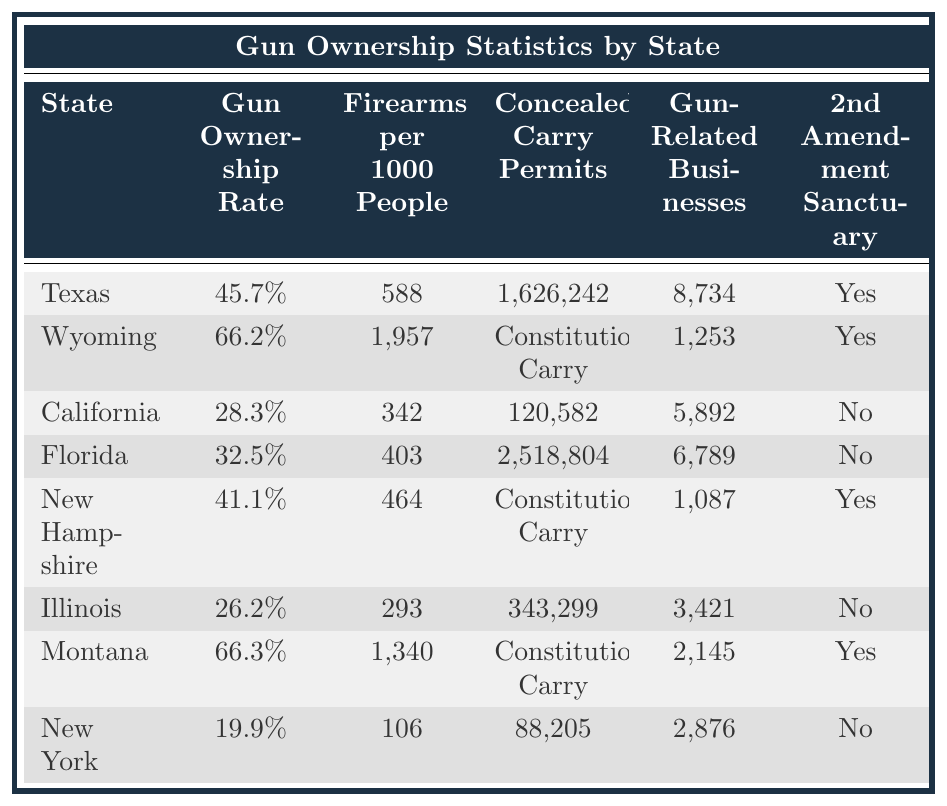What is the gun ownership rate in Texas? The table specifies the gun ownership rate for Texas as 45.7%.
Answer: 45.7% Which state has the highest firearms per 1000 people? In the table, Wyoming shows the highest firearms per 1000 people with a value of 1957.
Answer: Wyoming How many concealed carry permits are there in Florida? The table indicates that Florida has 2,518,804 concealed carry permits.
Answer: 2,518,804 Which states have a gun ownership rate above 40%? The table shows that Wyoming (66.2%), Montana (66.3%), and Texas (45.7%) have ownership rates above 40%.
Answer: Wyoming, Montana, Texas Is New York a Second Amendment Sanctuary state? According to the table, New York is marked as a "No" for being a Second Amendment Sanctuary state.
Answer: No What is the total number of concealed carry permits in Texas and Florida combined? The concealed carry permits in Texas are 1,626,242 and in Florida are 2,518,804. The total is 1,626,242 + 2,518,804 = 4,145,046.
Answer: 4,145,046 How many gun-related businesses are there in Montana compared to California? Montana has 2,145 gun-related businesses, while California has 5,892. Calculating the difference: 5,892 - 2,145 = 3,747.
Answer: 3,747 more in California Which state has a higher gun ownership rate, New Hampshire or Illinois? New Hampshire has a gun ownership rate of 41.1%, whereas Illinois has 26.2%. Comparing these values shows that New Hampshire has a higher rate.
Answer: New Hampshire Are there more gun-related businesses in Texas or in Wyoming? Texas has 8,734 gun-related businesses compared to Wyoming's 1,253. Since 8,734 is greater than 1,253, Texas has more.
Answer: Texas What is the average gun ownership rate for the states listed in the table? The states' gun ownership rates are Texas (45.7%), Wyoming (66.2%), California (28.3%), Florida (32.5%), New Hampshire (41.1%), Illinois (26.2%), Montana (66.3%), New York (19.9%). The average is (45.7 + 66.2 + 28.3 + 32.5 + 41.1 + 26.2 + 66.3 + 19.9) / 8 = 38.8%.
Answer: 38.8% 